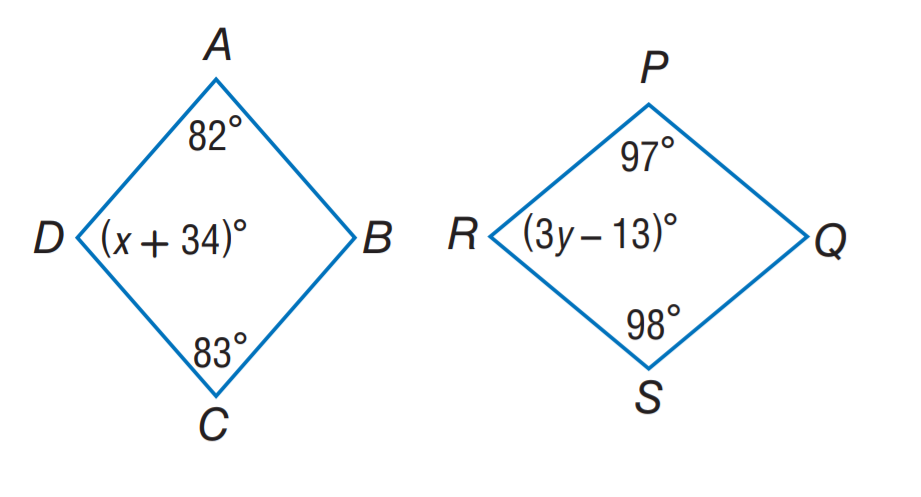Question: A B C D \sim Q S R P. Find x.
Choices:
A. 34
B. 63
C. 82
D. 83
Answer with the letter. Answer: B Question: A B C D \sim Q S R P. Find y.
Choices:
A. 13
B. 32
C. 34
D. 39
Answer with the letter. Answer: B 